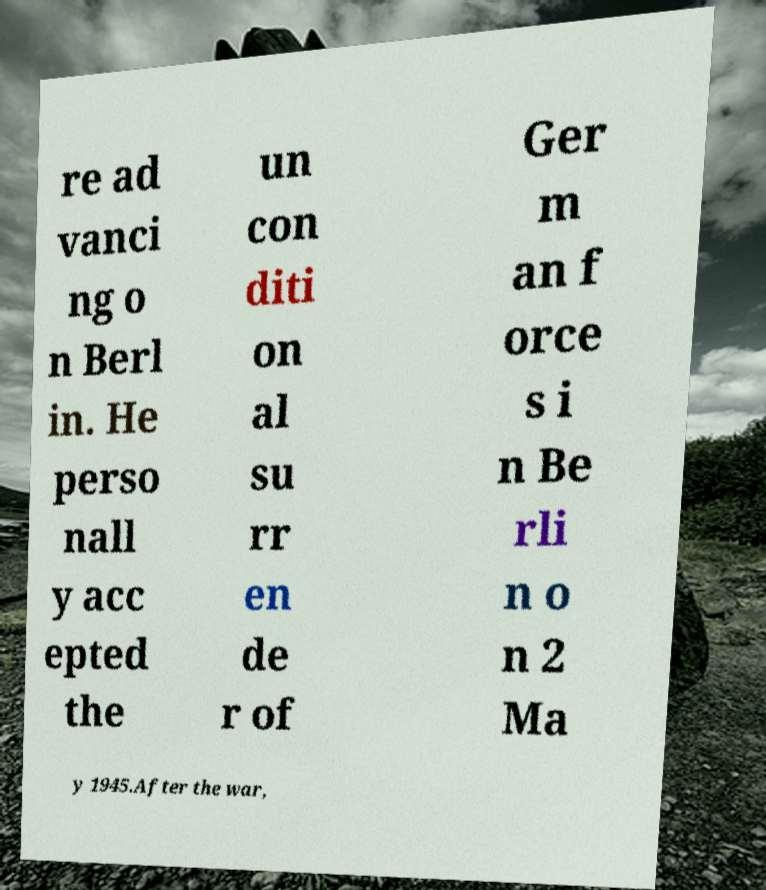What messages or text are displayed in this image? I need them in a readable, typed format. re ad vanci ng o n Berl in. He perso nall y acc epted the un con diti on al su rr en de r of Ger m an f orce s i n Be rli n o n 2 Ma y 1945.After the war, 